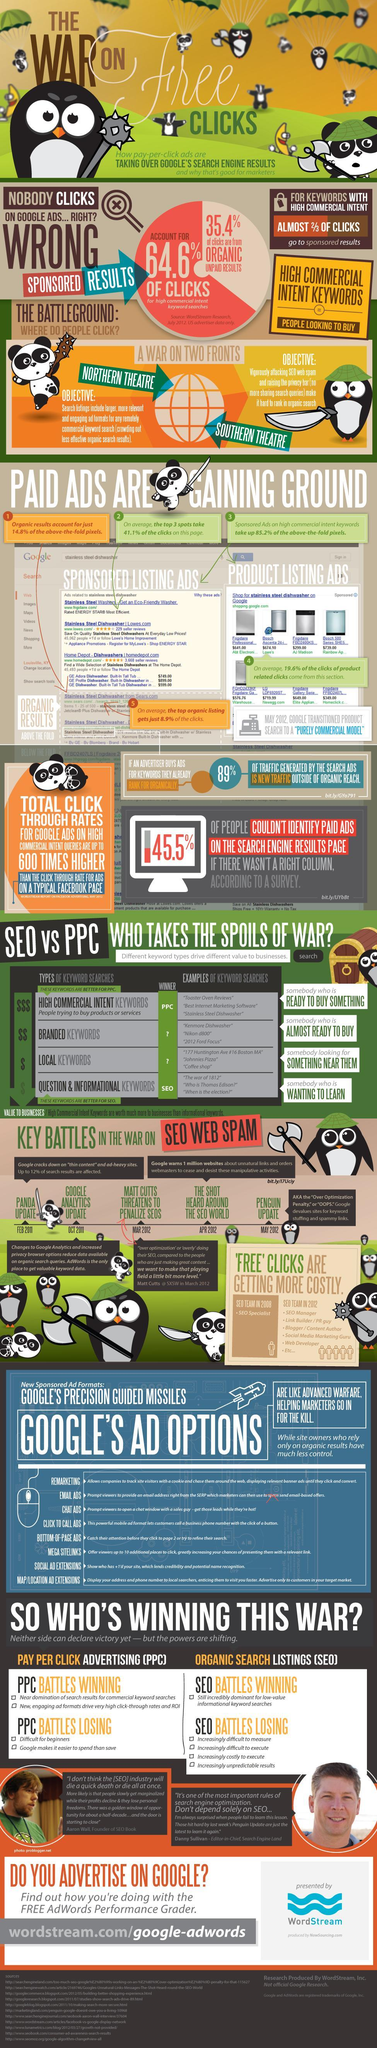What percent of the clicks are from organic unpaid results?
Answer the question with a short phrase. 35.4% What percent of the clicks are for high commercial intent keywords searches? 64.6% Where do majority of of the clicks for keywords with commercial intent lead to? Sponsored results 